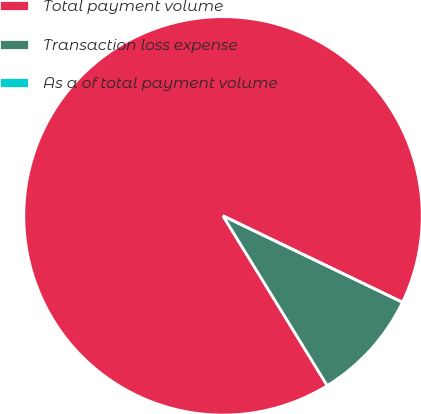<chart> <loc_0><loc_0><loc_500><loc_500><pie_chart><fcel>Total payment volume<fcel>Transaction loss expense<fcel>As a of total payment volume<nl><fcel>90.91%<fcel>9.09%<fcel>0.0%<nl></chart> 